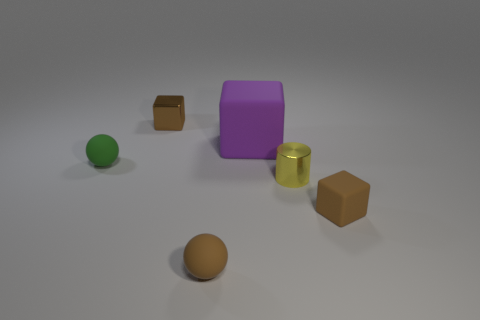Is there anything else that is the same size as the purple object?
Your answer should be very brief. No. Is the size of the green matte thing the same as the shiny cylinder?
Your response must be concise. Yes. What is the shape of the brown object that is both behind the tiny brown rubber ball and in front of the purple rubber thing?
Make the answer very short. Cube. How many other things have the same material as the yellow thing?
Offer a very short reply. 1. There is a brown matte thing left of the purple matte thing; what number of tiny green things are behind it?
Give a very brief answer. 1. What shape is the small brown thing that is right of the matte object in front of the brown matte thing that is right of the large matte object?
Offer a terse response. Cube. How many objects are large blue metal cubes or metal things?
Keep it short and to the point. 2. The shiny cube that is the same size as the green matte ball is what color?
Ensure brevity in your answer.  Brown. Do the purple thing and the small matte object behind the tiny yellow cylinder have the same shape?
Give a very brief answer. No. How many objects are either small brown things that are left of the tiny yellow shiny thing or tiny cubes to the right of the small brown ball?
Provide a short and direct response. 3. 